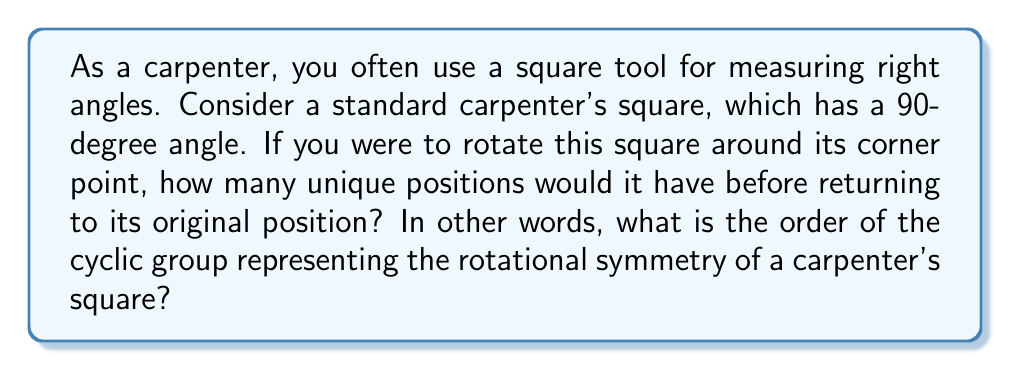Provide a solution to this math problem. Let's approach this step-by-step:

1) First, we need to understand what rotational symmetry means. It's the number of ways an object can be rotated around a fixed point and still look the same.

2) A carpenter's square has a 90-degree angle. This means that if we rotate it by 90 degrees, it will look different from its original position.

3) Let's consider the rotations:
   - 0° rotation (original position)
   - 90° rotation
   - 180° rotation
   - 270° rotation

4) After a 360° rotation, we're back to the original position. This means we have 4 unique positions.

5) In group theory, this rotational symmetry forms a cyclic group. The order of a cyclic group is the number of elements in the group.

6) Each rotation can be represented as an element in the group:
   $$\{e, r, r^2, r^3\}$$
   where $e$ is the identity (0° rotation), $r$ is a 90° rotation, $r^2$ is a 180° rotation, and $r^3$ is a 270° rotation.

7) The order of this group is 4, which corresponds to the number of unique rotations.

This can be visualized as:

[asy]
import geometry;

size(100);
draw((-1,-1)--(1,-1)--(1,1)--cycle, linewidth(2));
label("0°", (0,0), SE);
draw(rotate(90)*((0,0)--(1,-1)--(1,1)--cycle), linewidth(2));
label("90°", (0,0), SW);
draw(rotate(180)*((0,0)--(1,-1)--(1,1)--cycle), linewidth(2));
label("180°", (0,0), NW);
draw(rotate(270)*((0,0)--(1,-1)--(1,1)--cycle), linewidth(2));
label("270°", (0,0), NE);
[/asy]
Answer: The order of the cyclic group representing the rotational symmetry of a carpenter's square is 4. 